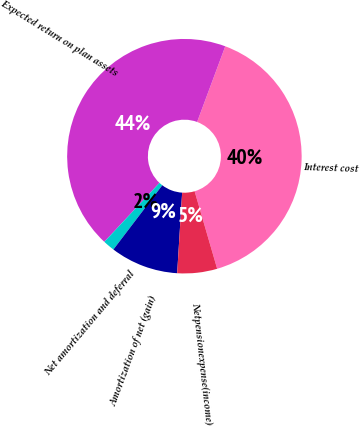<chart> <loc_0><loc_0><loc_500><loc_500><pie_chart><fcel>Interest cost<fcel>Expected return on plan assets<fcel>Net amortization and deferral<fcel>Amortization of net (gain)<fcel>Netpensionexpense(income)<nl><fcel>39.83%<fcel>43.71%<fcel>1.61%<fcel>9.37%<fcel>5.49%<nl></chart> 